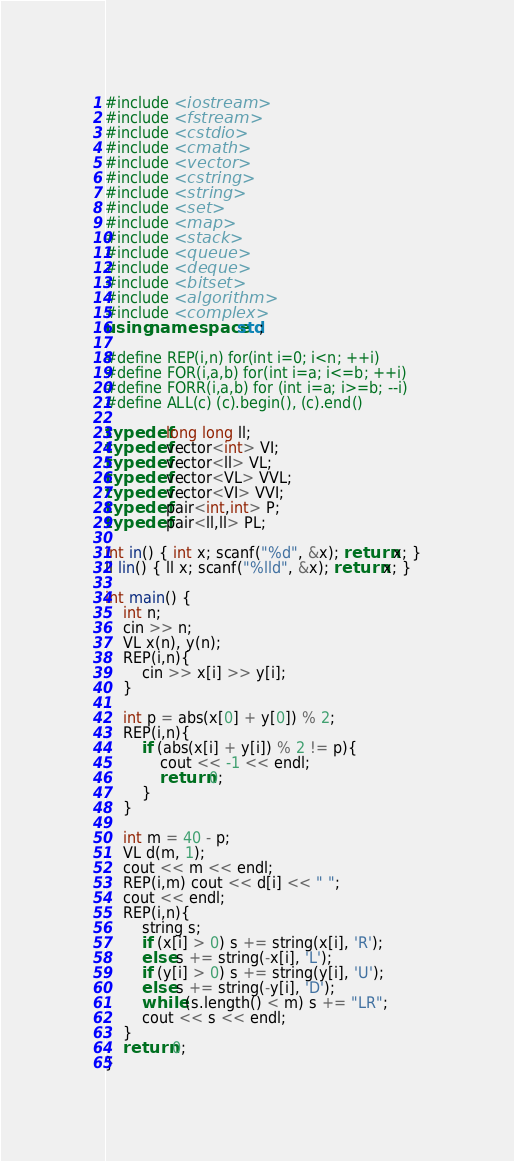Convert code to text. <code><loc_0><loc_0><loc_500><loc_500><_C++_>#include <iostream>
#include <fstream>
#include <cstdio>
#include <cmath>
#include <vector>
#include <cstring>
#include <string>
#include <set>
#include <map>
#include <stack>
#include <queue>
#include <deque>
#include <bitset>
#include <algorithm>
#include <complex>
using namespace std;
 
#define REP(i,n) for(int i=0; i<n; ++i)
#define FOR(i,a,b) for(int i=a; i<=b; ++i)
#define FORR(i,a,b) for (int i=a; i>=b; --i)
#define ALL(c) (c).begin(), (c).end()
 
typedef long long ll;
typedef vector<int> VI;
typedef vector<ll> VL;
typedef vector<VL> VVL;
typedef vector<VI> VVI;
typedef pair<int,int> P;
typedef pair<ll,ll> PL;

int in() { int x; scanf("%d", &x); return x; }
ll lin() { ll x; scanf("%lld", &x); return x; }

int main() {
    int n;
    cin >> n;
    VL x(n), y(n);
    REP(i,n){
        cin >> x[i] >> y[i];
    }

    int p = abs(x[0] + y[0]) % 2;
    REP(i,n){
        if (abs(x[i] + y[i]) % 2 != p){
            cout << -1 << endl;
            return 0;
        }
    }

    int m = 40 - p;
    VL d(m, 1);
    cout << m << endl;
    REP(i,m) cout << d[i] << " ";
    cout << endl;
    REP(i,n){
        string s;
        if (x[i] > 0) s += string(x[i], 'R');
        else s += string(-x[i], 'L');
        if (y[i] > 0) s += string(y[i], 'U');
        else s += string(-y[i], 'D');
        while (s.length() < m) s += "LR";
        cout << s << endl;
    }
    return 0;
}
</code> 